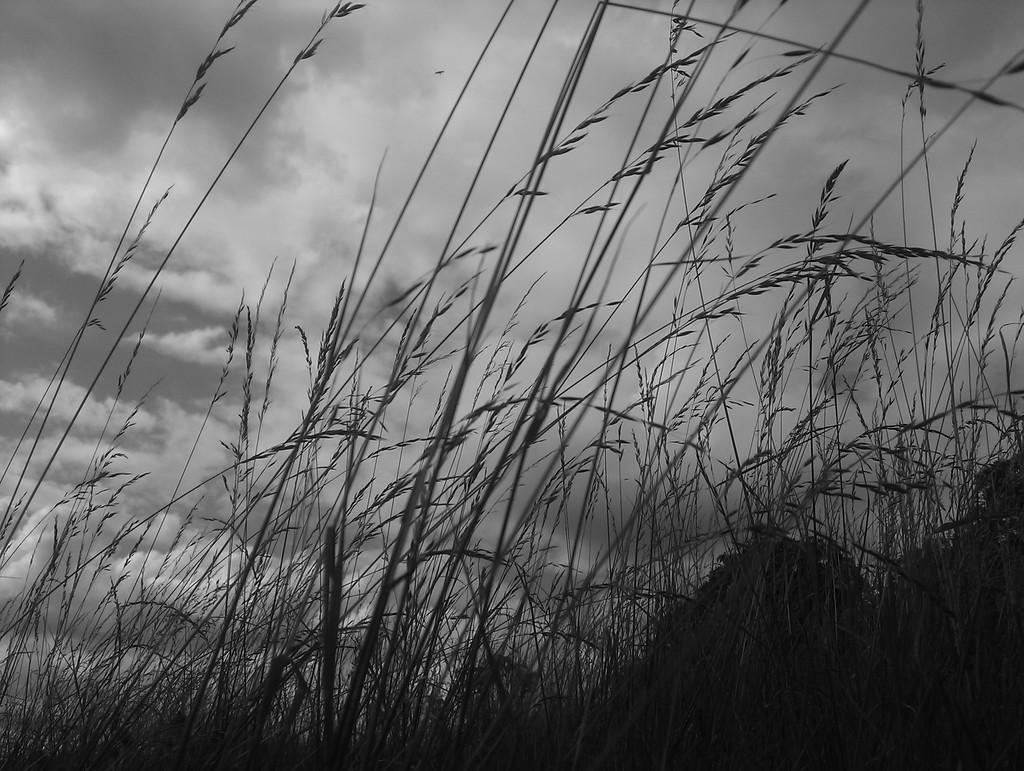What is the color scheme of the image? The image is black and white. What can be seen in the middle of the image? There is wheatgrass in the middle of the image. What is visible at the top of the image? The sky is visible at the top of the image. Can you tell me how many crackers are on the wheatgrass in the image? There are no crackers present in the image; it only features wheatgrass. What type of pancake is being served by the aunt in the image? There is no aunt or pancake present in the image. 